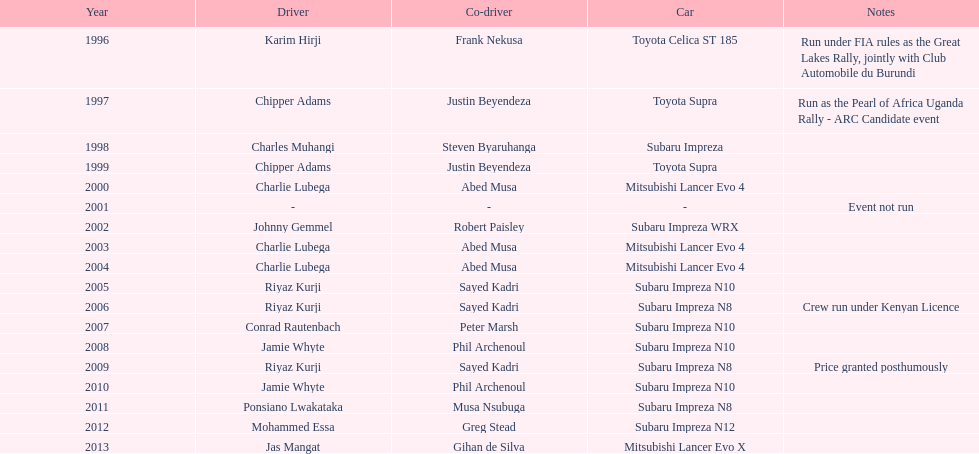Who is the sole driver with successive wins? Charlie Lubega. 